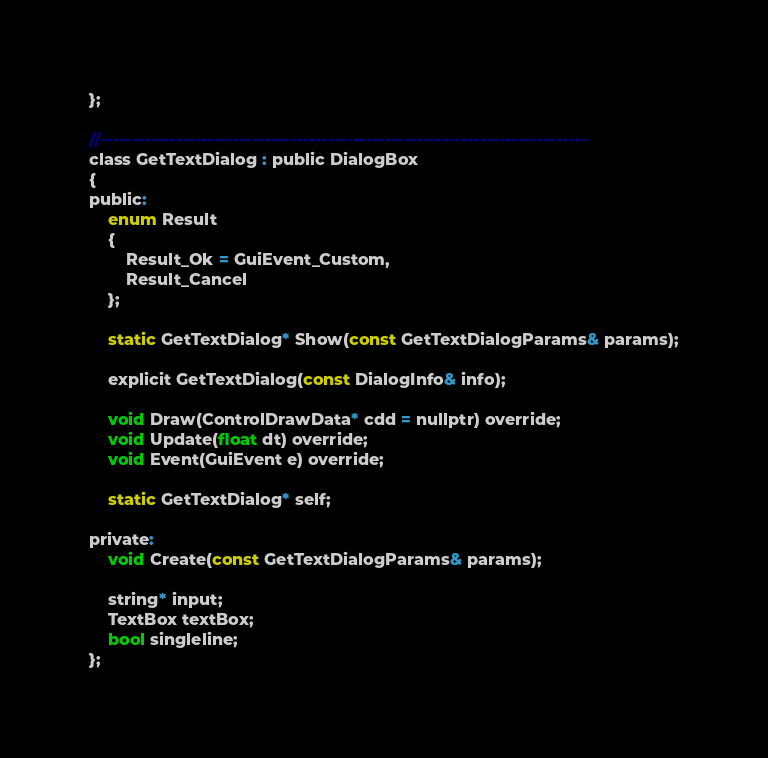Convert code to text. <code><loc_0><loc_0><loc_500><loc_500><_C_>};

//-----------------------------------------------------------------------------
class GetTextDialog : public DialogBox
{
public:
	enum Result
	{
		Result_Ok = GuiEvent_Custom,
		Result_Cancel
	};

	static GetTextDialog* Show(const GetTextDialogParams& params);

	explicit GetTextDialog(const DialogInfo& info);

	void Draw(ControlDrawData* cdd = nullptr) override;
	void Update(float dt) override;
	void Event(GuiEvent e) override;

	static GetTextDialog* self;

private:
	void Create(const GetTextDialogParams& params);

	string* input;
	TextBox textBox;
	bool singleline;
};
</code> 